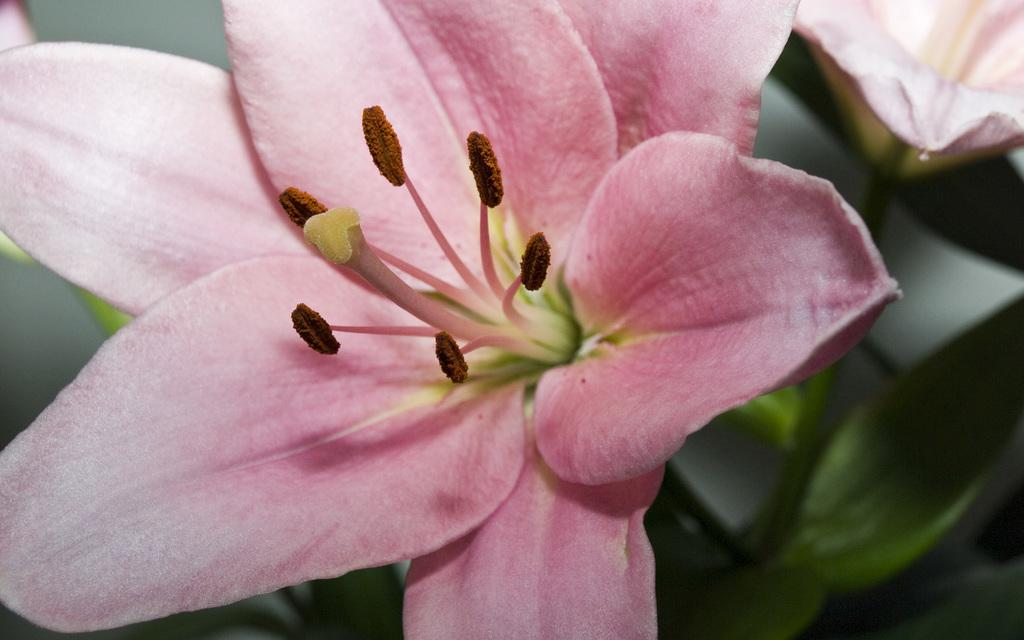What is the main subject of the image? There is a flower in the image. Can you describe the background of the image? The background of the image is blurry. How many mice are playing with the tooth in the image? There are no mice or tooth present in the image; it features a flower with a blurry background. 